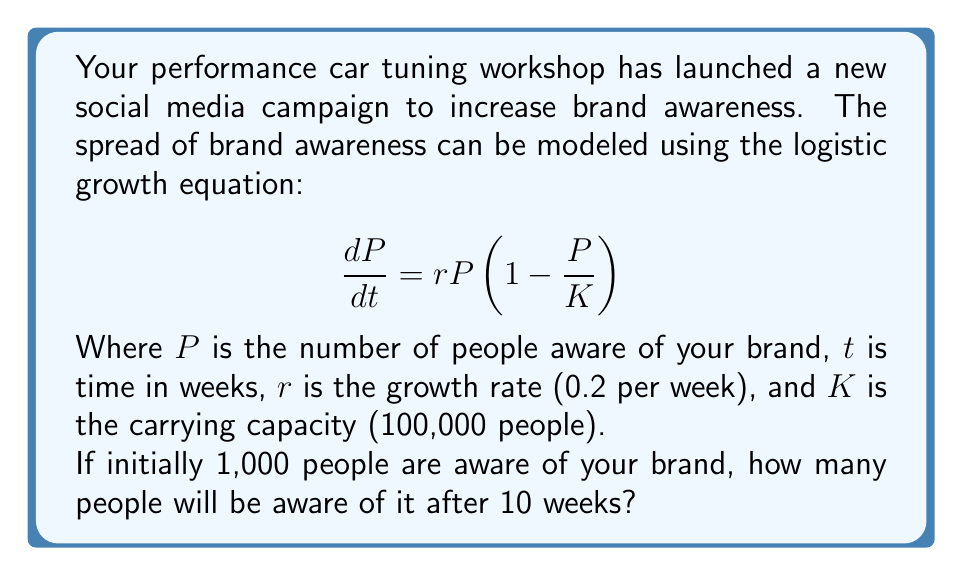Help me with this question. To solve this problem, we need to use the solution to the logistic growth equation:

$$P(t) = \frac{K}{1 + (\frac{K}{P_0} - 1)e^{-rt}}$$

Where $P_0$ is the initial population (brand awareness).

Given:
$K = 100,000$
$r = 0.2$ per week
$P_0 = 1,000$
$t = 10$ weeks

Let's substitute these values into the equation:

$$P(10) = \frac{100,000}{1 + (\frac{100,000}{1,000} - 1)e^{-0.2(10)}}$$

$$P(10) = \frac{100,000}{1 + (99)e^{-2}}$$

Now, let's calculate:
$e^{-2} \approx 0.1353$

$$P(10) = \frac{100,000}{1 + (99)(0.1353)}$$

$$P(10) = \frac{100,000}{1 + 13.3947}$$

$$P(10) = \frac{100,000}{14.3947}$$

$$P(10) \approx 6,947.65$$

Rounding to the nearest whole number, as we can't have fractional people:

$$P(10) \approx 6,948$$
Answer: 6,948 people 